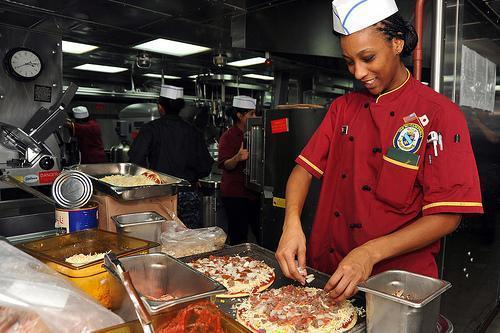How many people are in the kitchen?
Give a very brief answer. 4. 